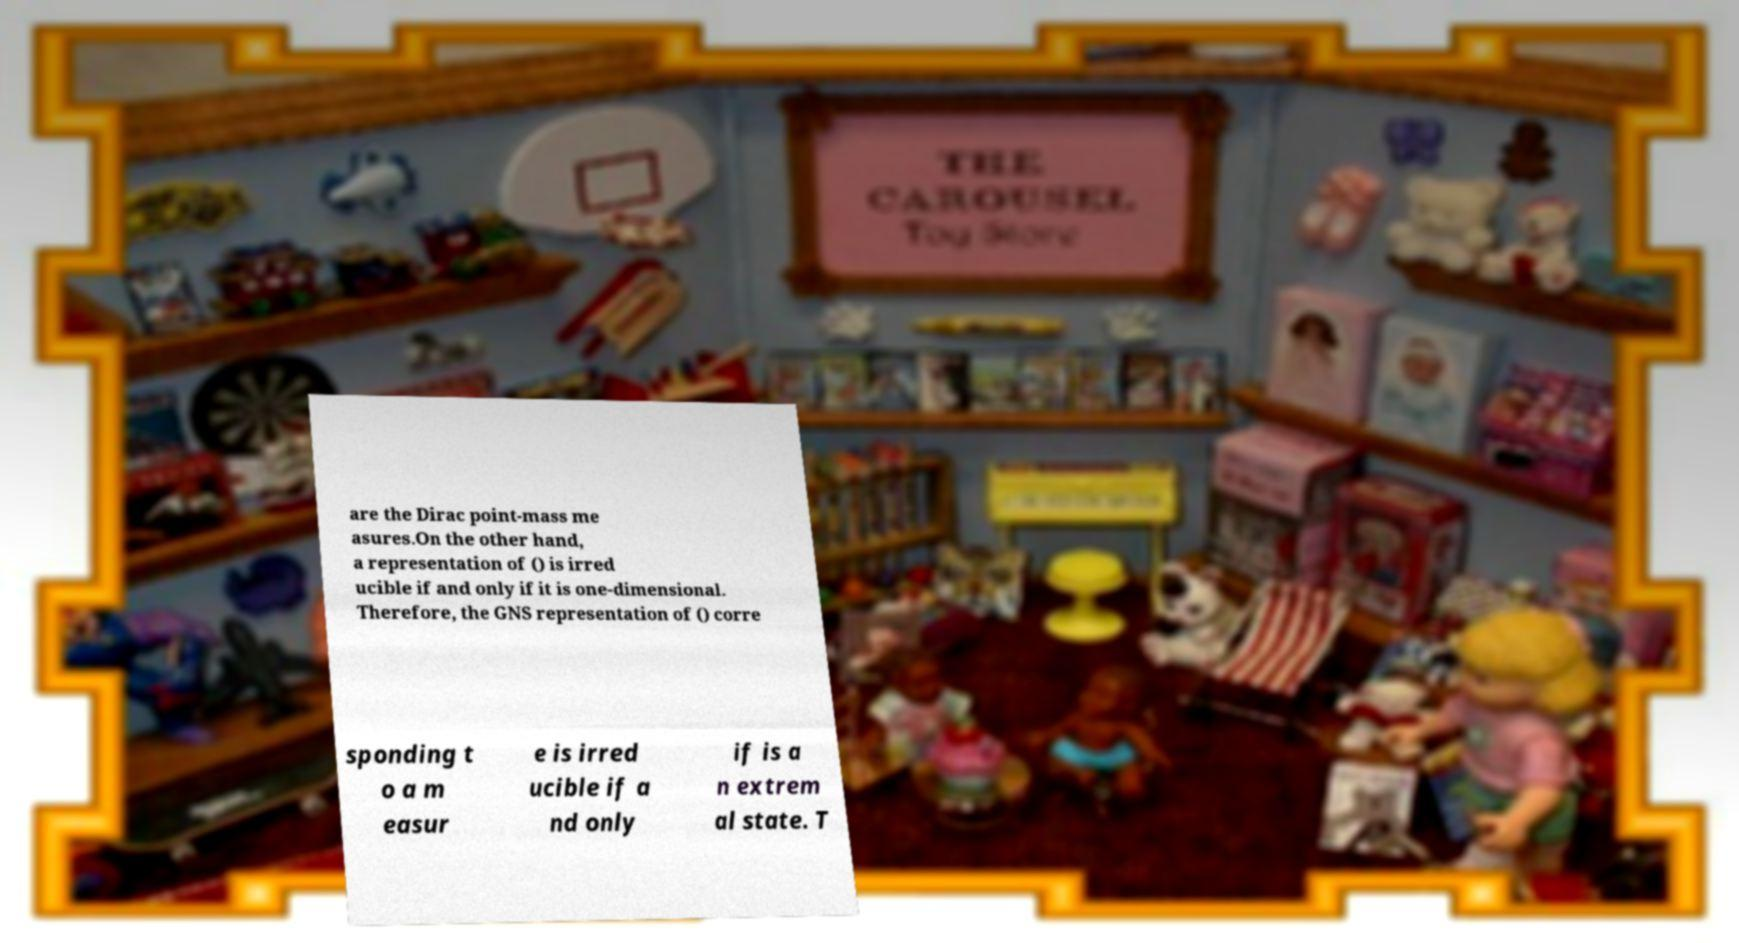Please read and relay the text visible in this image. What does it say? are the Dirac point-mass me asures.On the other hand, a representation of () is irred ucible if and only if it is one-dimensional. Therefore, the GNS representation of () corre sponding t o a m easur e is irred ucible if a nd only if is a n extrem al state. T 